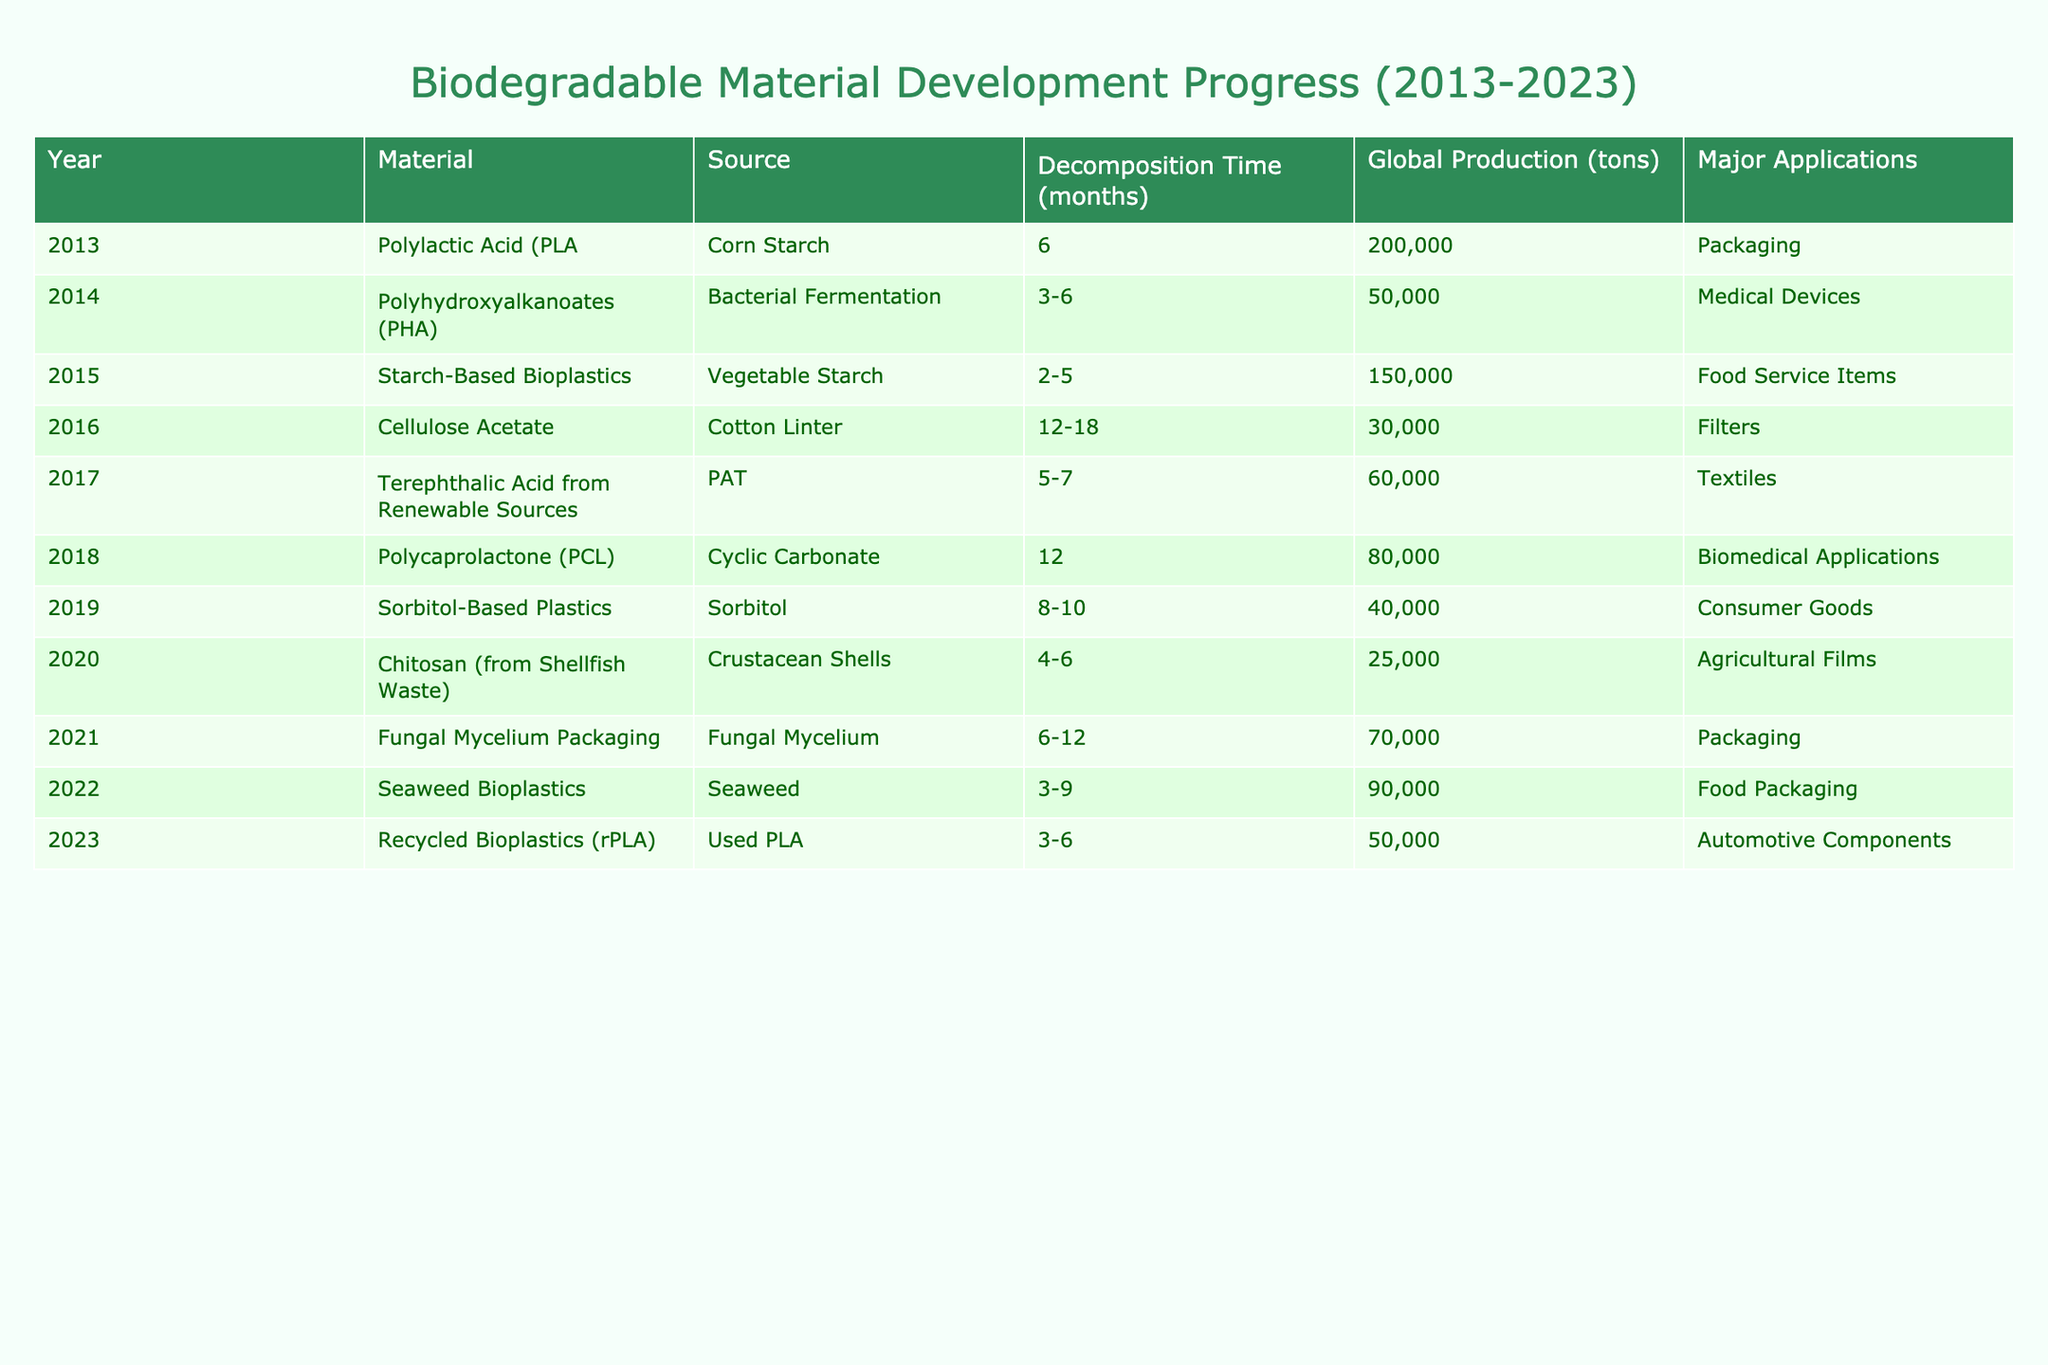What is the decomposition time of Polyhydroxyalkanoates (PHA)? The decomposition time for Polyhydroxyalkanoates (PHA) is listed in the table as 3-6 months. By directly looking at the relevant row for this material, we can find the specified range for decomposition time.
Answer: 3-6 months Which biodegradable material has the highest global production in 2015? The global production for Starch-Based Bioplastics in 2015 is listed as 150,000 tons, which is greater than any other material’s production listed for that year when comparing numbers.
Answer: Starch-Based Bioplastics What year saw the introduction of Seaweed Bioplastics? According to the table, Seaweed Bioplastics were introduced in 2022, as the corresponding row indicates this year for the material.
Answer: 2022 How many total tons of biodegradable materials were produced in the years 2016 and 2017 combined? For 2016, the global production was 30,000 tons and for 2017, it was 60,000 tons. Adding these two values together gives 30,000 + 60,000 = 90,000 tons.
Answer: 90,000 tons Was the decomposition time of Chitosan from Shellfish Waste greater than 6 months? The decomposition time for Chitosan from Shellfish Waste is stated as 4-6 months. Since this time does not exceed 6 months, it indicates that the statement is false.
Answer: No Which biodegradable material developed in 2018 has applications in biomedical contexts? The entry for Polycaprolactone (PCL) in 2018 specifies its use in biomedical applications, making this the correct answer when checking the applications associated with this material.
Answer: Polycaprolactone (PCL) What is the average decomposition time for the materials listed in 2020 and 2021? The decomposition time for Chitosan (2020) is 4-6 months and for Fungal Mycelium (2021) is 6-12 months. To find the average, we take the ranges into account: averaging the lower limits (4 + 6) / 2 = 5 months, and the upper limits (6 + 12) / 2 = 9 months, giving an average range of 5-9 months.
Answer: 5-9 months What percentage of total production in 2023 is attributed to Recycled Bioplastics? In 2023, the production of Recycled Bioplastics (rPLA) was 50,000 tons. Summing the total production across all years yields 1,385,000 tons (sum of all production). The percentage is calculated as (50,000 / 1,385,000) * 100 = approximately 3.61%.
Answer: 3.61% Which material was the last to enter production before 2023? Looking at the table, the last year before 2023 is 2022, which is when Seaweed Bioplastics were developed. Thus, this is the most recent material listed prior to 2023.
Answer: Seaweed Bioplastics Is there any biodegradable material in the table that originates from corn starch? By examining the materials listed in the table, Polylactic Acid (PLA) is shown to be derived from corn starch, confirming that such a material does exist.
Answer: Yes 